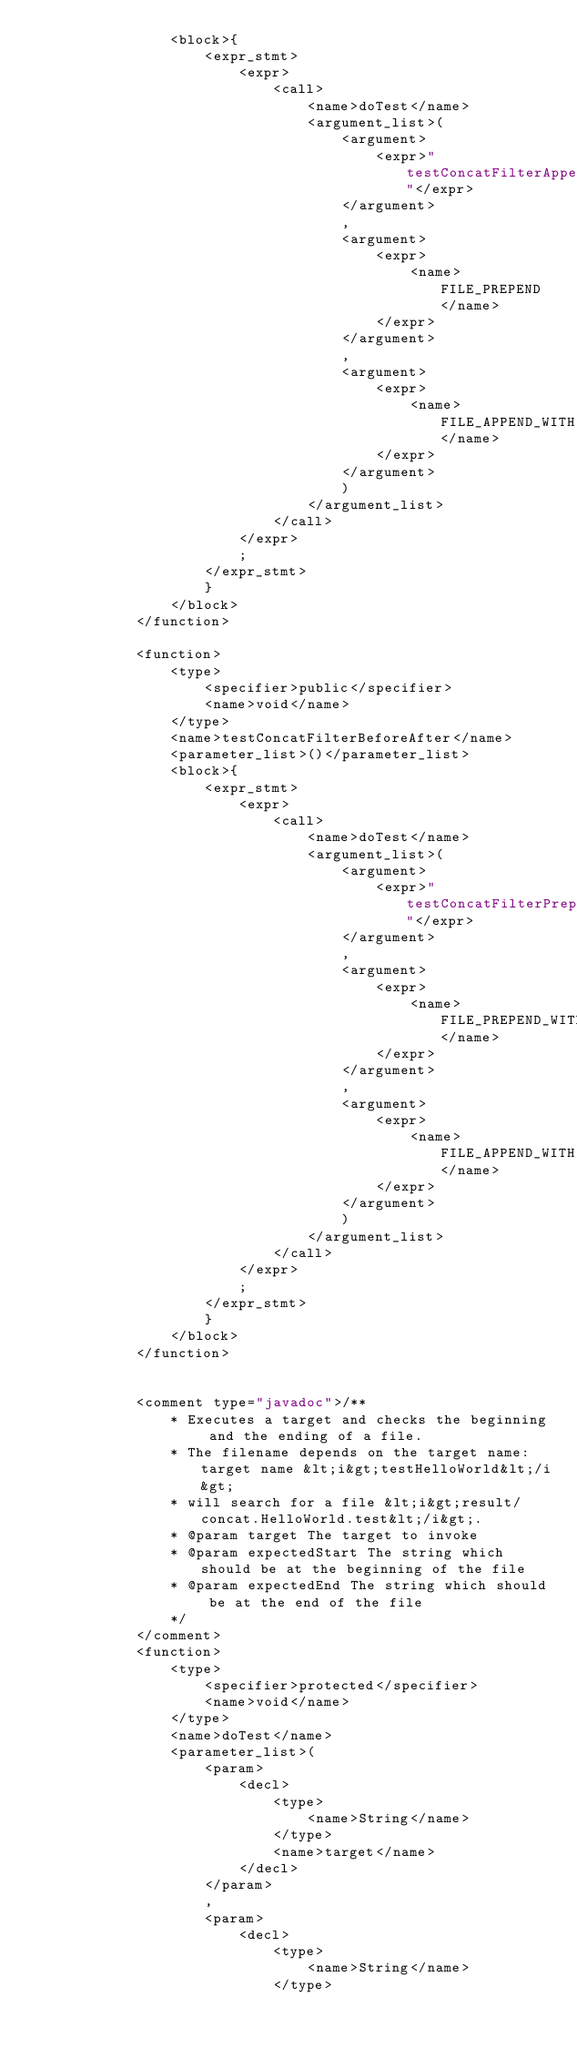Convert code to text. <code><loc_0><loc_0><loc_500><loc_500><_XML_>                <block>{
                    <expr_stmt>
                        <expr>
                            <call>
                                <name>doTest</name>
                                <argument_list>(
                                    <argument>
                                        <expr>"testConcatFilterAppend"</expr>
                                    </argument>
                                    ,
                                    <argument>
                                        <expr>
                                            <name>FILE_PREPEND</name>
                                        </expr>
                                    </argument>
                                    ,
                                    <argument>
                                        <expr>
                                            <name>FILE_APPEND_WITH</name>
                                        </expr>
                                    </argument>
                                    )
                                </argument_list>
                            </call>
                        </expr>
                        ;
                    </expr_stmt>
                    }
                </block>
            </function>

            <function>
                <type>
                    <specifier>public</specifier>
                    <name>void</name>
                </type>
                <name>testConcatFilterBeforeAfter</name>
                <parameter_list>()</parameter_list>
                <block>{
                    <expr_stmt>
                        <expr>
                            <call>
                                <name>doTest</name>
                                <argument_list>(
                                    <argument>
                                        <expr>"testConcatFilterPrependAppend"</expr>
                                    </argument>
                                    ,
                                    <argument>
                                        <expr>
                                            <name>FILE_PREPEND_WITH</name>
                                        </expr>
                                    </argument>
                                    ,
                                    <argument>
                                        <expr>
                                            <name>FILE_APPEND_WITH</name>
                                        </expr>
                                    </argument>
                                    )
                                </argument_list>
                            </call>
                        </expr>
                        ;
                    </expr_stmt>
                    }
                </block>
            </function>


            <comment type="javadoc">/**
                * Executes a target and checks the beginning and the ending of a file.
                * The filename depends on the target name: target name &lt;i&gt;testHelloWorld&lt;/i&gt;
                * will search for a file &lt;i&gt;result/concat.HelloWorld.test&lt;/i&gt;.
                * @param target The target to invoke
                * @param expectedStart The string which should be at the beginning of the file
                * @param expectedEnd The string which should be at the end of the file
                */
            </comment>
            <function>
                <type>
                    <specifier>protected</specifier>
                    <name>void</name>
                </type>
                <name>doTest</name>
                <parameter_list>(
                    <param>
                        <decl>
                            <type>
                                <name>String</name>
                            </type>
                            <name>target</name>
                        </decl>
                    </param>
                    ,
                    <param>
                        <decl>
                            <type>
                                <name>String</name>
                            </type></code> 